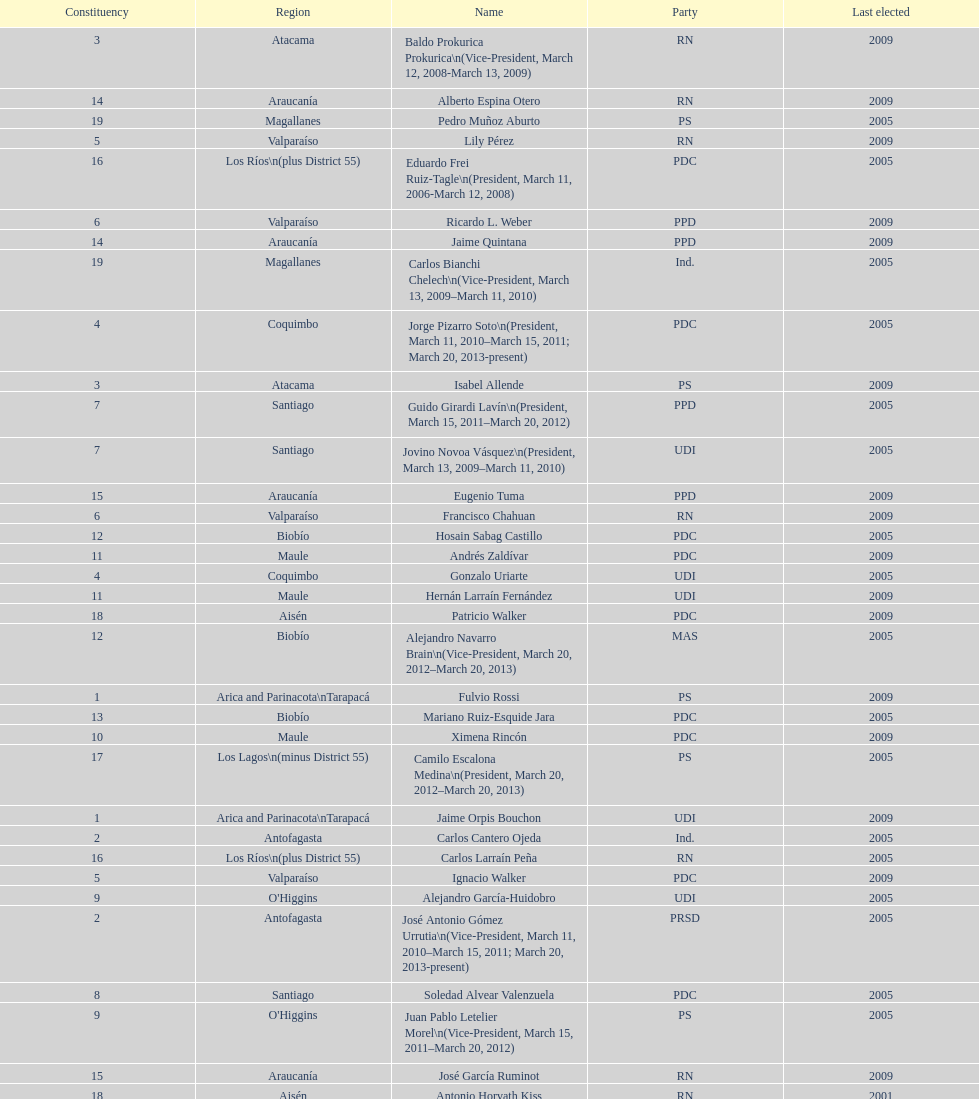What is the first name on the table? Fulvio Rossi. 